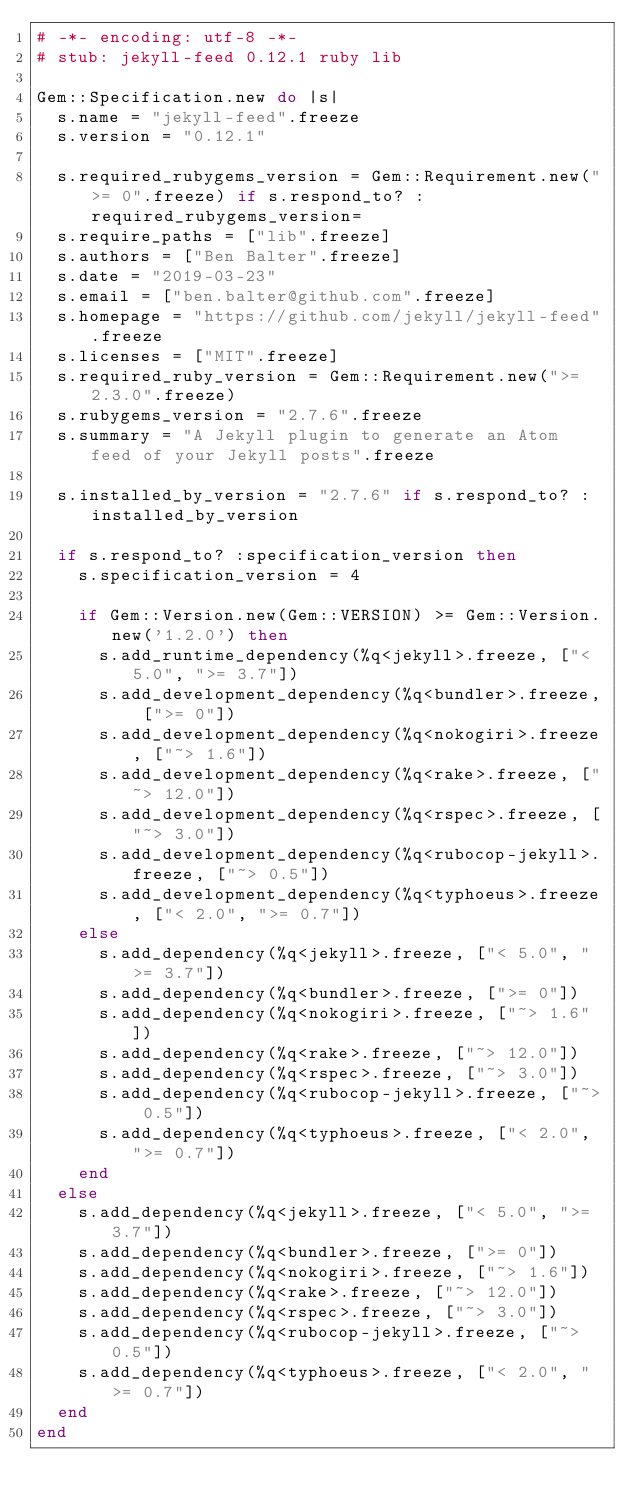Convert code to text. <code><loc_0><loc_0><loc_500><loc_500><_Ruby_># -*- encoding: utf-8 -*-
# stub: jekyll-feed 0.12.1 ruby lib

Gem::Specification.new do |s|
  s.name = "jekyll-feed".freeze
  s.version = "0.12.1"

  s.required_rubygems_version = Gem::Requirement.new(">= 0".freeze) if s.respond_to? :required_rubygems_version=
  s.require_paths = ["lib".freeze]
  s.authors = ["Ben Balter".freeze]
  s.date = "2019-03-23"
  s.email = ["ben.balter@github.com".freeze]
  s.homepage = "https://github.com/jekyll/jekyll-feed".freeze
  s.licenses = ["MIT".freeze]
  s.required_ruby_version = Gem::Requirement.new(">= 2.3.0".freeze)
  s.rubygems_version = "2.7.6".freeze
  s.summary = "A Jekyll plugin to generate an Atom feed of your Jekyll posts".freeze

  s.installed_by_version = "2.7.6" if s.respond_to? :installed_by_version

  if s.respond_to? :specification_version then
    s.specification_version = 4

    if Gem::Version.new(Gem::VERSION) >= Gem::Version.new('1.2.0') then
      s.add_runtime_dependency(%q<jekyll>.freeze, ["< 5.0", ">= 3.7"])
      s.add_development_dependency(%q<bundler>.freeze, [">= 0"])
      s.add_development_dependency(%q<nokogiri>.freeze, ["~> 1.6"])
      s.add_development_dependency(%q<rake>.freeze, ["~> 12.0"])
      s.add_development_dependency(%q<rspec>.freeze, ["~> 3.0"])
      s.add_development_dependency(%q<rubocop-jekyll>.freeze, ["~> 0.5"])
      s.add_development_dependency(%q<typhoeus>.freeze, ["< 2.0", ">= 0.7"])
    else
      s.add_dependency(%q<jekyll>.freeze, ["< 5.0", ">= 3.7"])
      s.add_dependency(%q<bundler>.freeze, [">= 0"])
      s.add_dependency(%q<nokogiri>.freeze, ["~> 1.6"])
      s.add_dependency(%q<rake>.freeze, ["~> 12.0"])
      s.add_dependency(%q<rspec>.freeze, ["~> 3.0"])
      s.add_dependency(%q<rubocop-jekyll>.freeze, ["~> 0.5"])
      s.add_dependency(%q<typhoeus>.freeze, ["< 2.0", ">= 0.7"])
    end
  else
    s.add_dependency(%q<jekyll>.freeze, ["< 5.0", ">= 3.7"])
    s.add_dependency(%q<bundler>.freeze, [">= 0"])
    s.add_dependency(%q<nokogiri>.freeze, ["~> 1.6"])
    s.add_dependency(%q<rake>.freeze, ["~> 12.0"])
    s.add_dependency(%q<rspec>.freeze, ["~> 3.0"])
    s.add_dependency(%q<rubocop-jekyll>.freeze, ["~> 0.5"])
    s.add_dependency(%q<typhoeus>.freeze, ["< 2.0", ">= 0.7"])
  end
end
</code> 